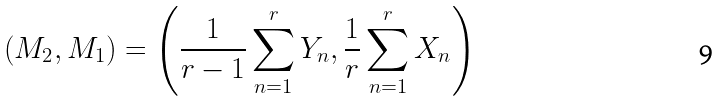Convert formula to latex. <formula><loc_0><loc_0><loc_500><loc_500>\left ( M _ { 2 } , M _ { 1 } \right ) = \left ( \frac { 1 } { r - 1 } \sum _ { n = 1 } ^ { r } Y _ { n } , \frac { 1 } { r } \sum _ { n = 1 } ^ { r } X _ { n } \right )</formula> 